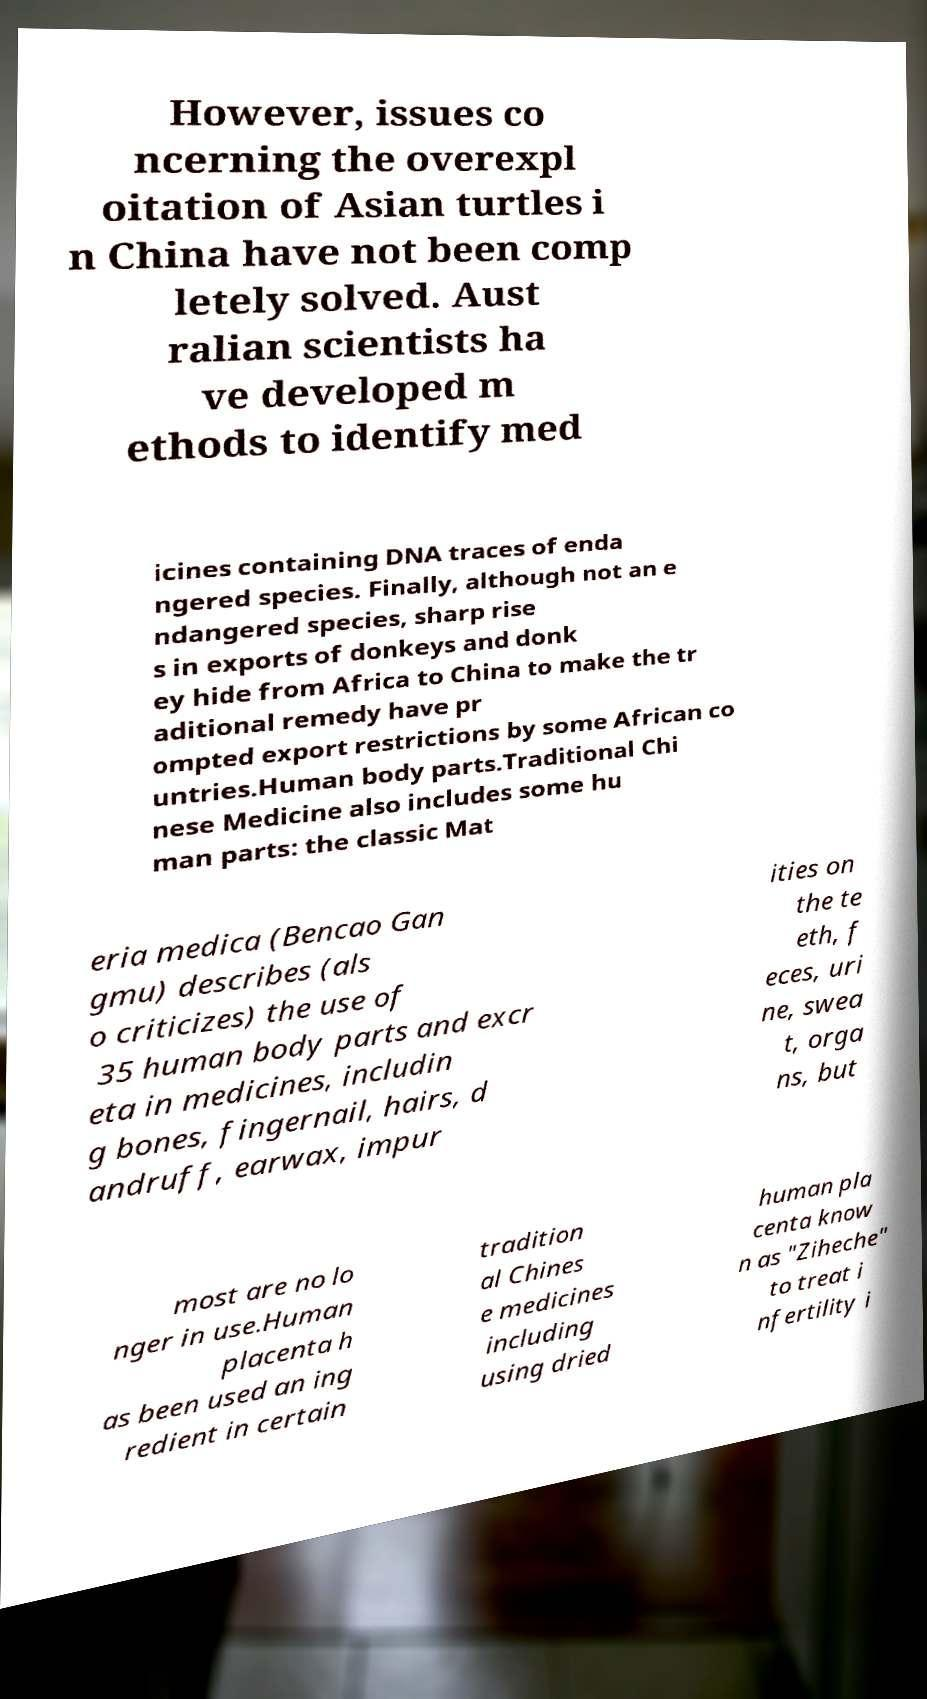For documentation purposes, I need the text within this image transcribed. Could you provide that? However, issues co ncerning the overexpl oitation of Asian turtles i n China have not been comp letely solved. Aust ralian scientists ha ve developed m ethods to identify med icines containing DNA traces of enda ngered species. Finally, although not an e ndangered species, sharp rise s in exports of donkeys and donk ey hide from Africa to China to make the tr aditional remedy have pr ompted export restrictions by some African co untries.Human body parts.Traditional Chi nese Medicine also includes some hu man parts: the classic Mat eria medica (Bencao Gan gmu) describes (als o criticizes) the use of 35 human body parts and excr eta in medicines, includin g bones, fingernail, hairs, d andruff, earwax, impur ities on the te eth, f eces, uri ne, swea t, orga ns, but most are no lo nger in use.Human placenta h as been used an ing redient in certain tradition al Chines e medicines including using dried human pla centa know n as "Ziheche" to treat i nfertility i 